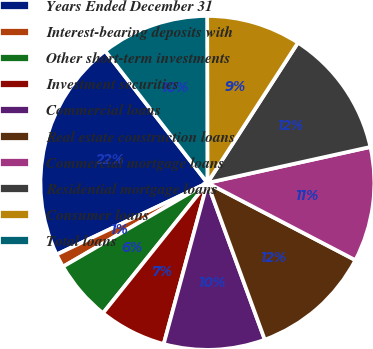Convert chart. <chart><loc_0><loc_0><loc_500><loc_500><pie_chart><fcel>Years Ended December 31<fcel>Interest-bearing deposits with<fcel>Other short-term investments<fcel>Investment securities<fcel>Commercial loans<fcel>Real estate construction loans<fcel>Commercial mortgage loans<fcel>Residential mortgage loans<fcel>Consumer loans<fcel>Total loans<nl><fcel>21.57%<fcel>1.31%<fcel>5.88%<fcel>6.54%<fcel>9.8%<fcel>11.76%<fcel>11.11%<fcel>12.42%<fcel>9.15%<fcel>10.46%<nl></chart> 